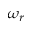Convert formula to latex. <formula><loc_0><loc_0><loc_500><loc_500>\omega _ { r }</formula> 